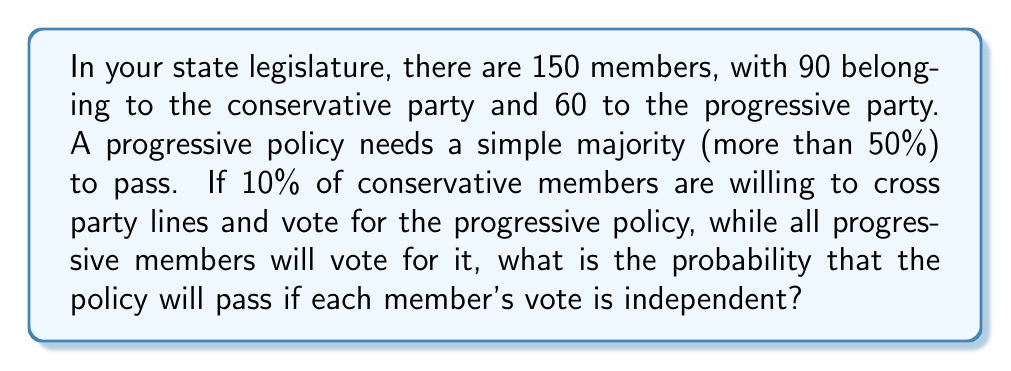Can you solve this math problem? Let's approach this step-by-step:

1) We need at least 76 votes (50% + 1) for the policy to pass.

2) All 60 progressive members will vote for the policy.

3) We need at least 16 conservative members to vote for the policy.

4) There are 90 conservative members, and 10% (0.1 * 90 = 9) are willing to cross party lines.

5) We can model this as a binomial distribution, where:
   n = 90 (total conservative members)
   p = 0.1 (probability of a conservative member voting for the policy)
   k ≥ 16 (we need at least 16 conservative votes)

6) The probability of the policy passing is the probability of getting 16 or more conservative votes.

7) We can calculate this using the cumulative binomial probability:

   $$P(X \geq 16) = 1 - P(X < 16) = 1 - \sum_{k=0}^{15} \binom{90}{k} (0.1)^k (0.9)^{90-k}$$

8) Using a calculator or computer (as this is a complex calculation):

   $$P(X \geq 16) \approx 0.0228$$

Therefore, the probability of the policy passing is approximately 0.0228 or 2.28%.
Answer: 0.0228 